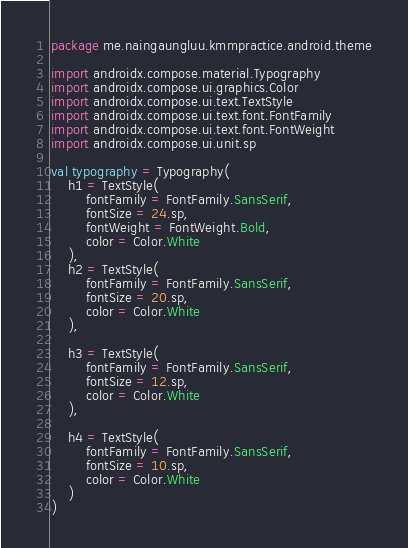Convert code to text. <code><loc_0><loc_0><loc_500><loc_500><_Kotlin_>package me.naingaungluu.kmmpractice.android.theme

import androidx.compose.material.Typography
import androidx.compose.ui.graphics.Color
import androidx.compose.ui.text.TextStyle
import androidx.compose.ui.text.font.FontFamily
import androidx.compose.ui.text.font.FontWeight
import androidx.compose.ui.unit.sp

val typography = Typography(
    h1 = TextStyle(
        fontFamily = FontFamily.SansSerif,
        fontSize = 24.sp,
        fontWeight = FontWeight.Bold,
        color = Color.White
    ),
    h2 = TextStyle(
        fontFamily = FontFamily.SansSerif,
        fontSize = 20.sp,
        color = Color.White
    ),

    h3 = TextStyle(
        fontFamily = FontFamily.SansSerif,
        fontSize = 12.sp,
        color = Color.White
    ),

    h4 = TextStyle(
        fontFamily = FontFamily.SansSerif,
        fontSize = 10.sp,
        color = Color.White
    )
)</code> 